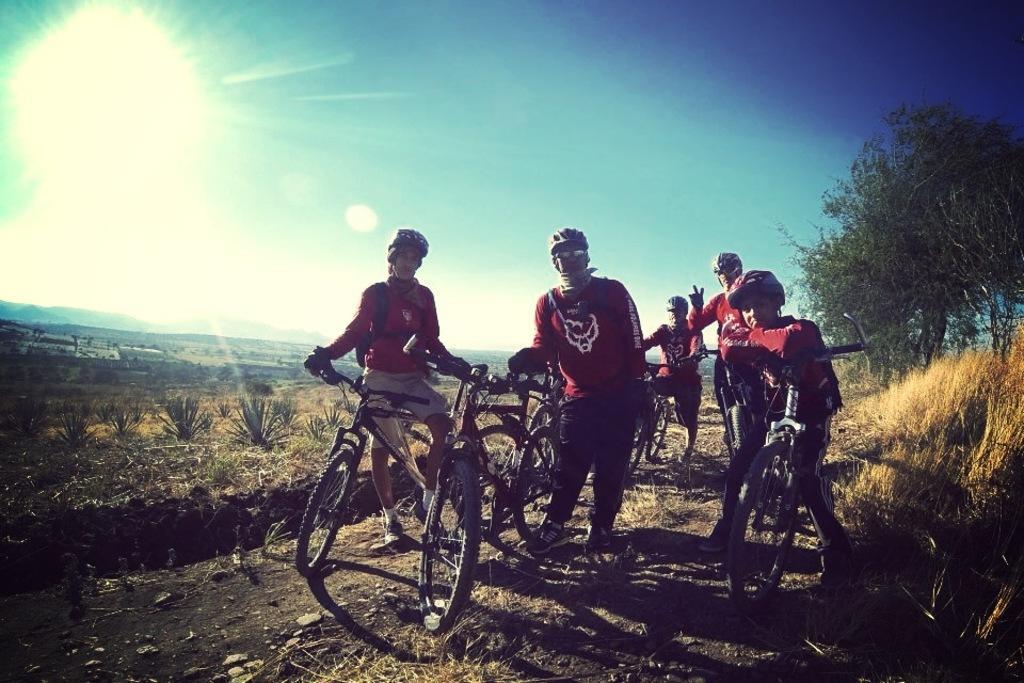In one or two sentences, can you explain what this image depicts? In this image there is a man standing near the bicycles, another group of people standing near the bicycles , and in back ground there are plants, grass , trees, sky,sun. 